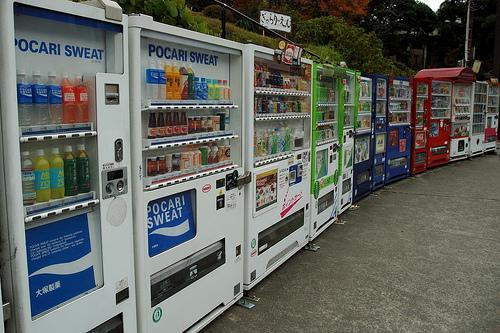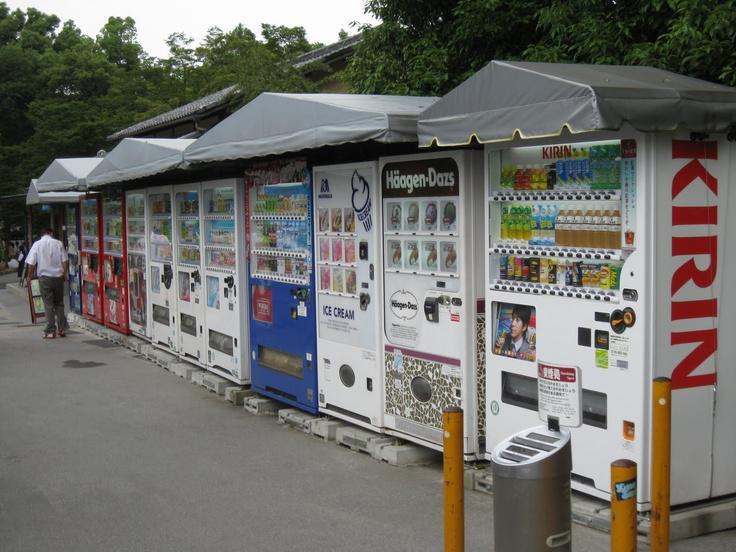The first image is the image on the left, the second image is the image on the right. For the images shown, is this caption "A standing person is visible only at the far end of a long row of vending machines." true? Answer yes or no. Yes. The first image is the image on the left, the second image is the image on the right. For the images shown, is this caption "There is at least one person standing outside near the machines in the image on the right." true? Answer yes or no. Yes. 